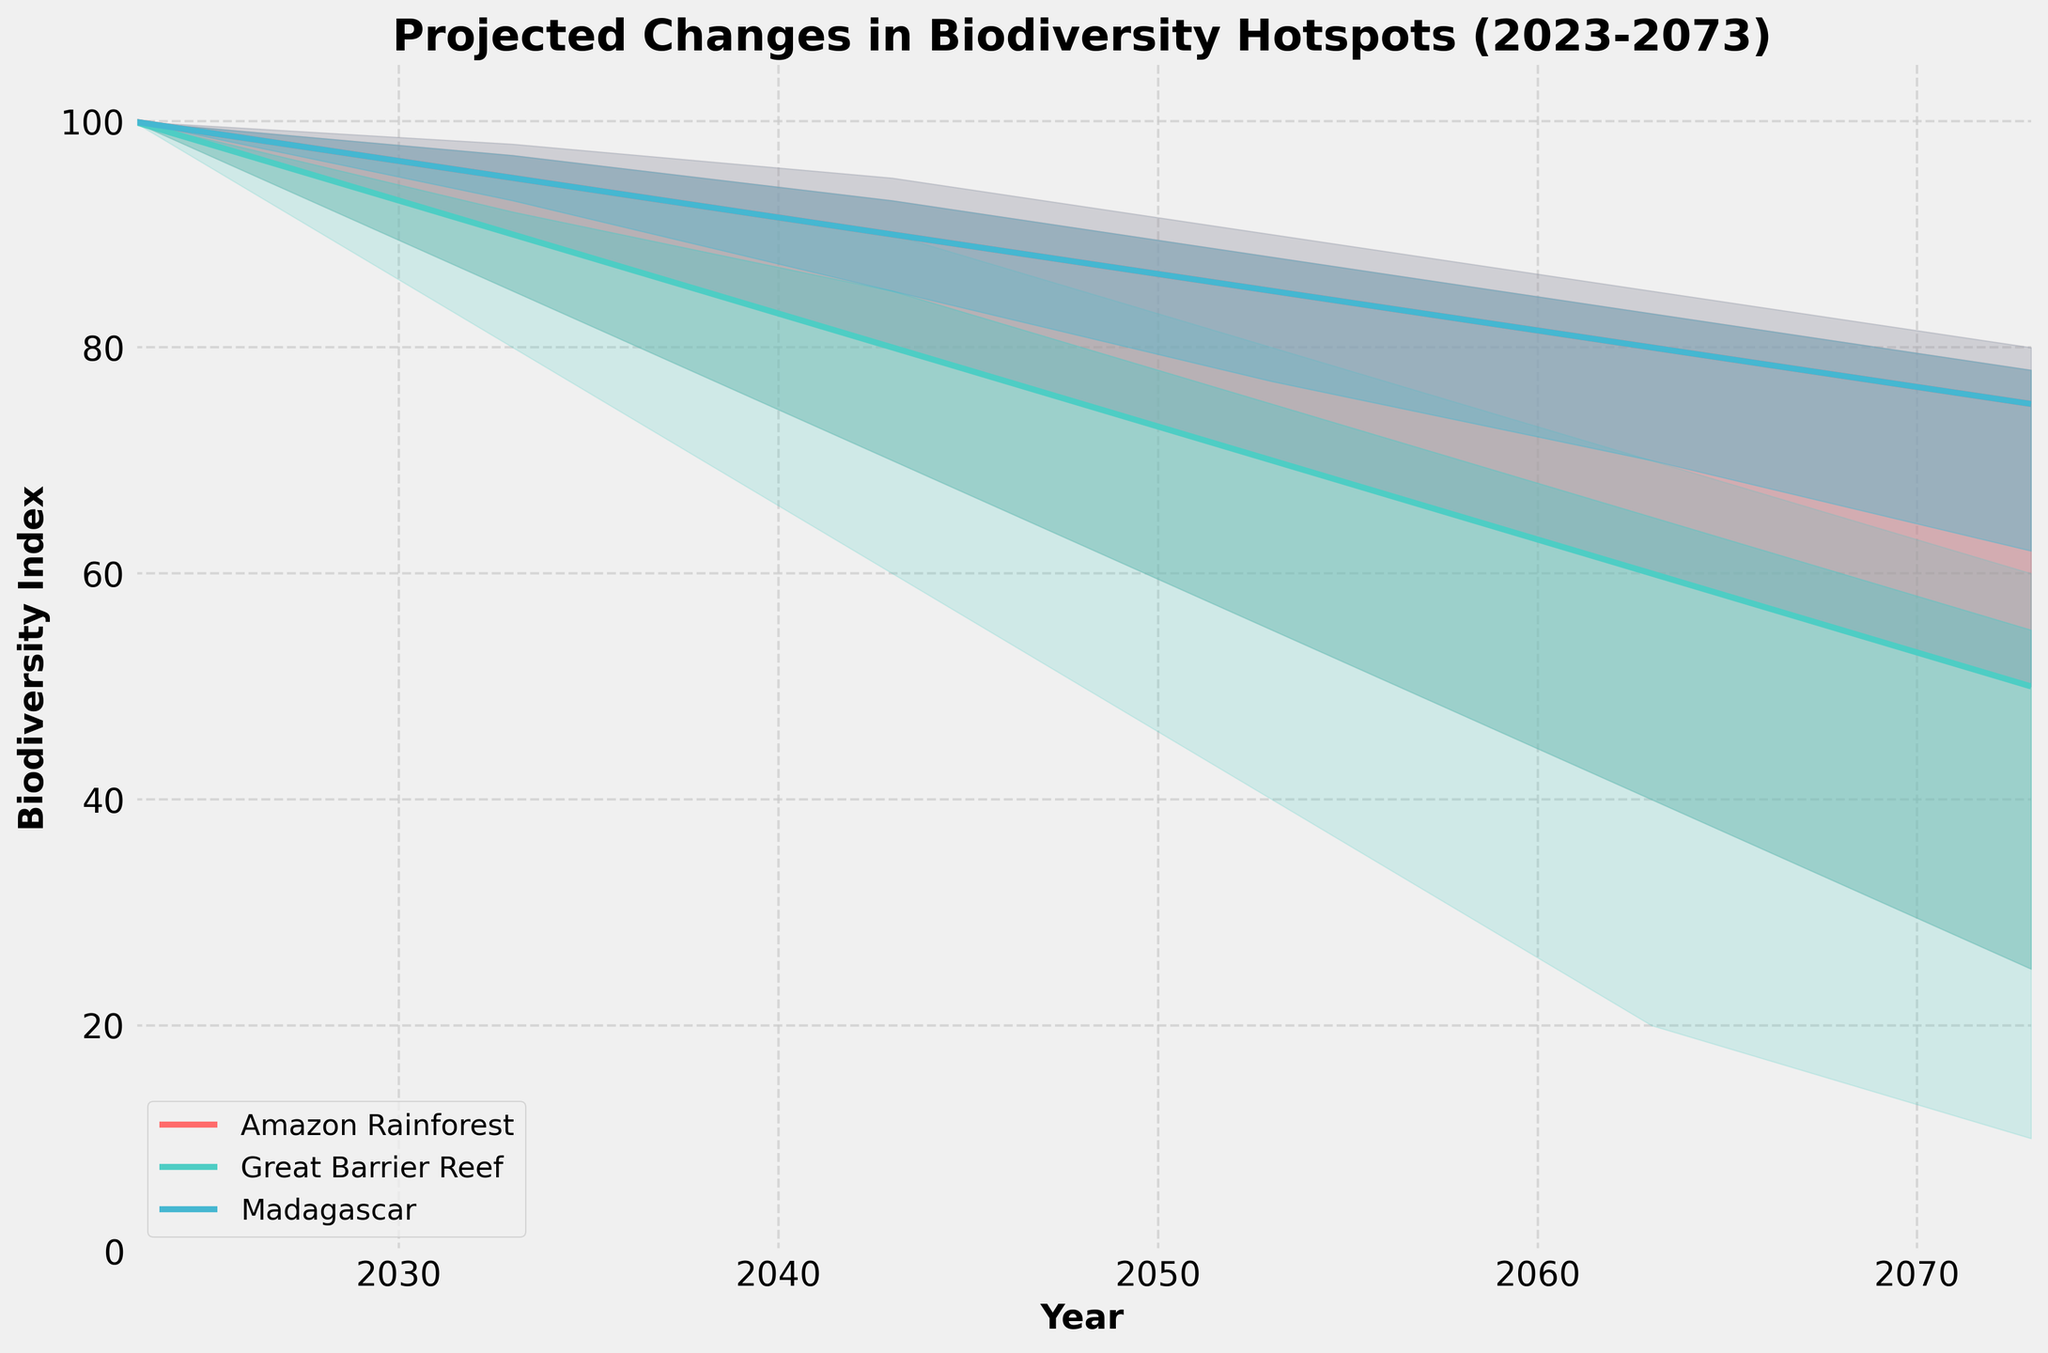What is the title of the chart? The title of the chart is displayed at the top of the figure and provides a summary of what the figure represents. The title is "Projected Changes in Biodiversity Hotspots (2023-2073)"
Answer: Projected Changes in Biodiversity Hotspots (2023-2073) How many regions are displayed in the chart? By looking at the legend and the different lines and shaded areas, we can see that three regions are mentioned: Amazon Rainforest, Great Barrier Reef, and Madagascar
Answer: 3 Which region shows the steepest decline in biodiversity indices between 2023 and 2073? Comparing the slopes of the median lines for each region, the Great Barrier Reef shows the steepest decline in biodiversity indices over the specified period
Answer: Great Barrier Reef What is the Lower Bound biodiversity index for the Amazon Rainforest in 2073? The Lower Bound value for the Amazon Rainforest is found at the bottom of the fan for the year 2073 and is 25
Answer: 25 Which region has the highest 80th Percentile biodiversity index in 2063? By looking at the 80th Percentile lines for all regions in 2063, we see that Madagascar has the highest 80th Percentile index value of 83
Answer: Madagascar What is the difference between the Median biodiversity indices of Amazon Rainforest and Great Barrier Reef in 2043? The Median value for Amazon Rainforest in 2043 is 90, and for Great Barrier Reef, it is 80. The difference is 90 - 80 = 10
Answer: 10 What is the range of the biodiversity index for the Great Barrier Reef in 2053? The range is calculated as the difference between the Upper Bound and Lower Bound values for the Great Barrier Reef in 2053: 80 - 40 = 40
Answer: 40 Which year shows a median biodiversity index of 50 for the Great Barrier Reef? By inspecting the median line for the Great Barrier Reef, we see that the median biodiversity index is 50 in the year 2073
Answer: 2073 Which region shows a consistent trend from 2023 to 2073, and how would you describe it? Analyzing the median trends, Madagascar shows a consistent decline over this period, gradually declining from 100 in 2023 to 75 in 2073
Answer: Madagascar, consistent decline Approximately what percentile value is the median for Amazon Rainforest in 2063? Since median is defined as the 50th percentile, looking at the chart, the median value of Amazon Rainforest for 2063 is 80, making it also the 50th percentile
Answer: 50th percentile 